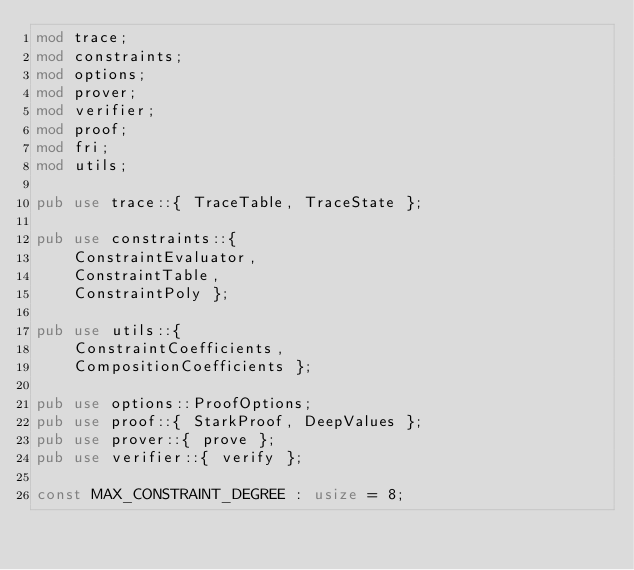<code> <loc_0><loc_0><loc_500><loc_500><_Rust_>mod trace;
mod constraints;
mod options;
mod prover;
mod verifier;
mod proof;
mod fri;
mod utils;

pub use trace::{ TraceTable, TraceState };

pub use constraints::{
    ConstraintEvaluator,
    ConstraintTable,
    ConstraintPoly };

pub use utils::{
    ConstraintCoefficients,
    CompositionCoefficients };

pub use options::ProofOptions;
pub use proof::{ StarkProof, DeepValues };
pub use prover::{ prove };
pub use verifier::{ verify };

const MAX_CONSTRAINT_DEGREE : usize = 8;</code> 